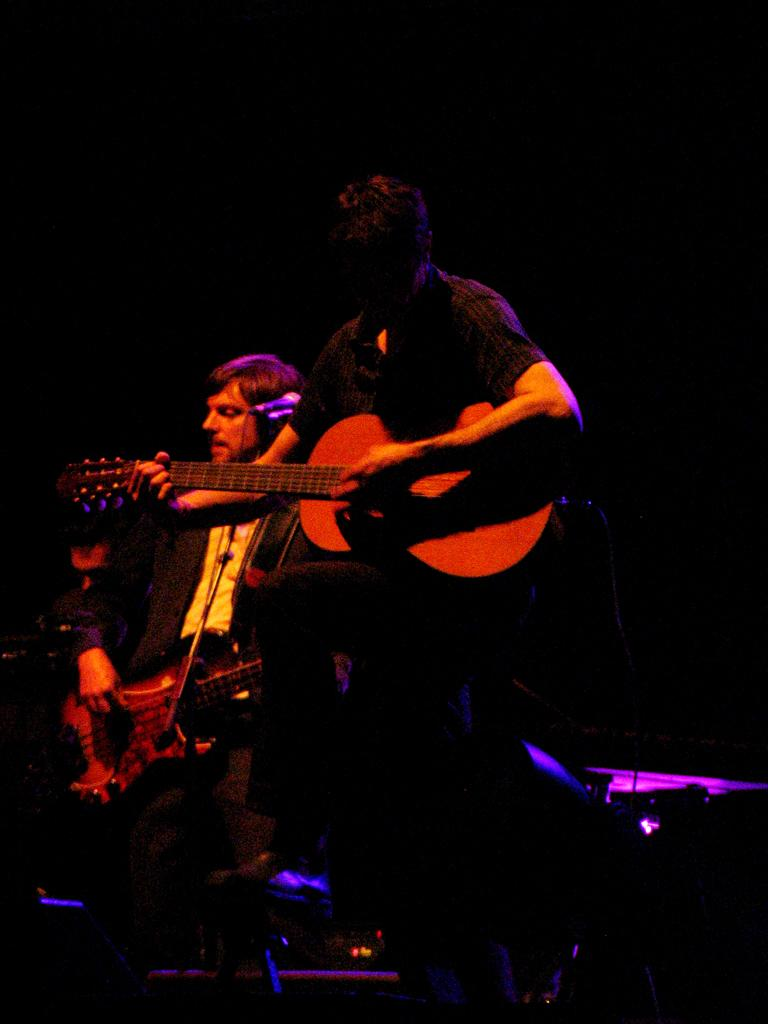What are the two people in the image doing? The two people in the image are standing and playing guitar. What can be seen attached to a mic stand in the image? There is a mic attached to a mic stand in the image. How would you describe the lighting in the background of the image? The background appears dark in the image. How many people are standing in the image? There are three people standing in the image. Can you see any leaves falling from the trees in the image? There are no trees or leaves visible in the image. What type of approval is the person in the image seeking from the audience? There is no indication in the image that the person is seeking approval from the audience. 